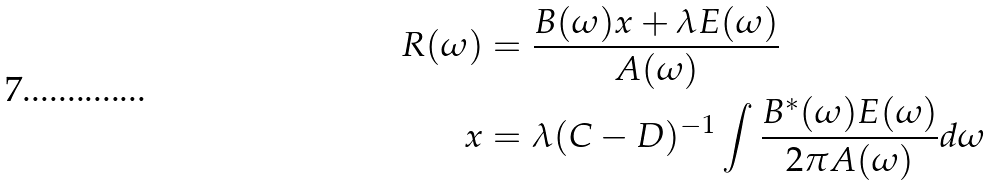Convert formula to latex. <formula><loc_0><loc_0><loc_500><loc_500>R ( \omega ) & = \frac { B ( \omega ) x + \lambda E ( \omega ) } { A ( \omega ) } \\ x & = \lambda ( C - D ) ^ { - 1 } \int \frac { B ^ { * } ( \omega ) E ( \omega ) } { 2 \pi A ( \omega ) } d \omega</formula> 